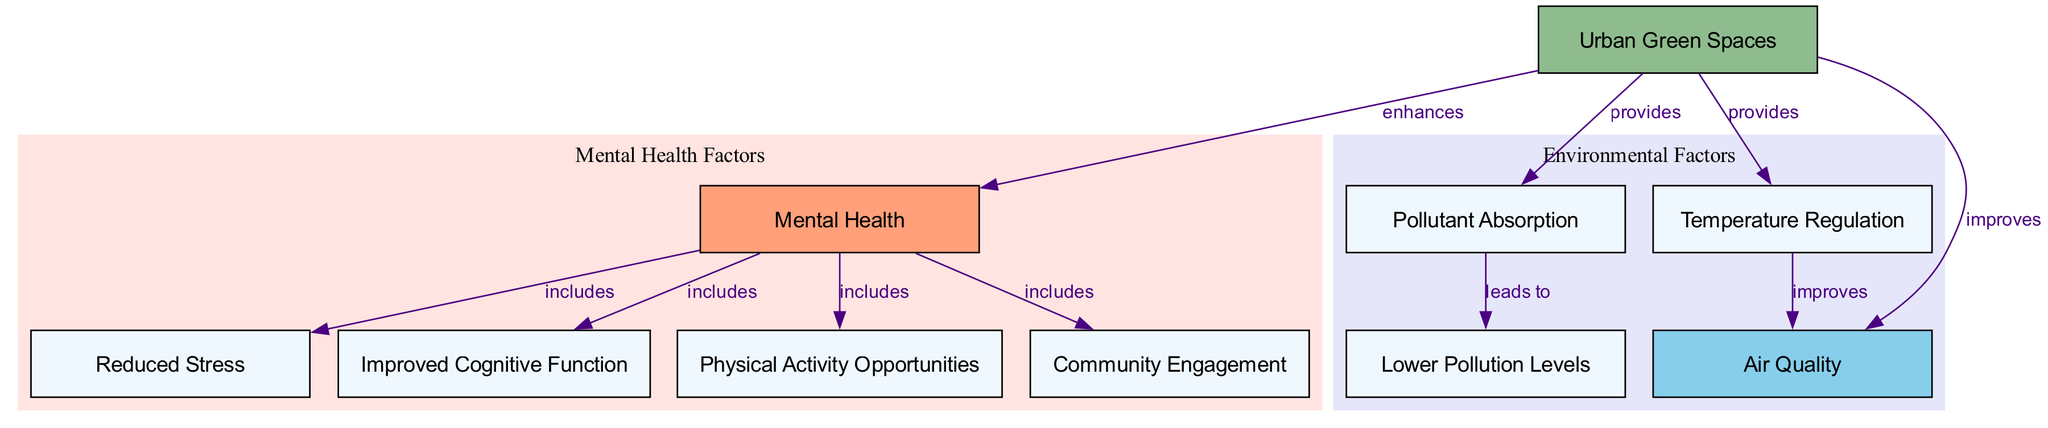What are the two main categories of factors in this diagram? The diagram is divided into two distinct clusters: one labeled "Environmental Factors" and the other "Mental Health Factors." These clusters group related nodes, indicating that urban green spaces affect both air quality and mental health in separate, but interconnected ways.
Answer: Environmental Factors, Mental Health Factors How many nodes represent factors related to Mental Health? In the "Mental Health Factors" cluster, five nodes are listed: "Mental Health," "Reduced Stress," "Improved Cognitive Function," "Physical Activity Opportunities," and "Community Engagement." Counting these nodes provides the answer.
Answer: 5 Which node improves Air Quality? The diagram indicates that "Urban Green Spaces" directly improves "Air Quality," as specified by the edge connecting these two nodes with the label "improves." This relationship indicates a direct positive impact.
Answer: Urban Green Spaces What is the relationship between Pollutant Absorption and Lower Pollution Levels? The edge connecting "Pollutant Absorption" to "Lower Pollution Levels" has the label "leads to," establishing a cause-and-effect relationship where the absorption of pollutants by green spaces results in lower pollution levels in the surrounding air.
Answer: leads to Which factor is linked to both Reduced Stress and Improved Cognitive Function? The node "Mental Health" is connected to both "Reduced Stress" and "Improved Cognitive Function" with edges labeled "includes," suggesting that mental health encompasses these two aspects as benefits arising from urban green spaces.
Answer: Mental Health What is the connection type between Urban Green Spaces and Temperature Regulation? The edge from "Urban Green Spaces" to "Temperature Regulation" is labeled "provides," indicating that urban green spaces provide temperature regulation as a direct benefit, affecting overall air quality as well.
Answer: provides How many edges connect Urban Green Spaces to other nodes? By reviewing the connections in the diagram, "Urban Green Spaces" has four directed edges leading to different nodes: "Air Quality," "Mental Health," "Pollutant Absorption," and "Temperature Regulation." This indicates the diverse benefits offered by green spaces.
Answer: 4 How does Temperature Regulation affect Air Quality? The relationship diagrammed shows "Temperature Regulation" improving "Air Quality," meaning that effective temperature regulation, potentially through shading and heat absorption, positively influences the quality of the air in urban settings.
Answer: improves 